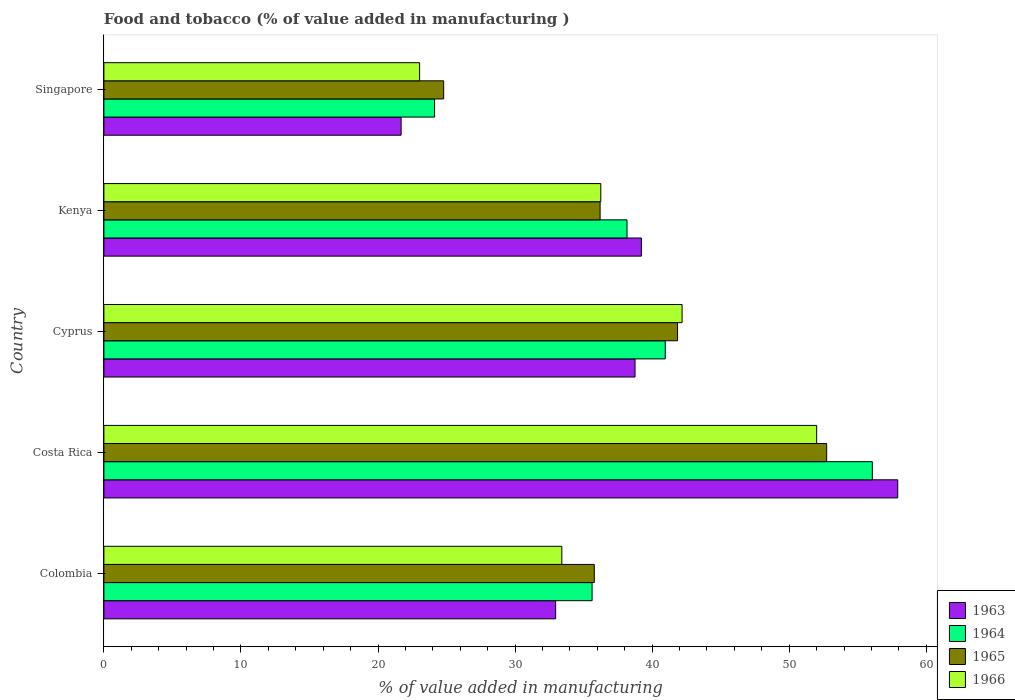How many groups of bars are there?
Provide a succinct answer. 5. Are the number of bars on each tick of the Y-axis equal?
Provide a succinct answer. Yes. How many bars are there on the 1st tick from the top?
Make the answer very short. 4. What is the value added in manufacturing food and tobacco in 1964 in Singapore?
Give a very brief answer. 24.13. Across all countries, what is the maximum value added in manufacturing food and tobacco in 1966?
Your response must be concise. 52. Across all countries, what is the minimum value added in manufacturing food and tobacco in 1966?
Your answer should be compact. 23.04. In which country was the value added in manufacturing food and tobacco in 1965 minimum?
Your answer should be compact. Singapore. What is the total value added in manufacturing food and tobacco in 1965 in the graph?
Offer a very short reply. 191.36. What is the difference between the value added in manufacturing food and tobacco in 1964 in Costa Rica and that in Cyprus?
Keep it short and to the point. 15.11. What is the difference between the value added in manufacturing food and tobacco in 1963 in Costa Rica and the value added in manufacturing food and tobacco in 1965 in Singapore?
Your answer should be very brief. 33.13. What is the average value added in manufacturing food and tobacco in 1966 per country?
Give a very brief answer. 37.38. What is the difference between the value added in manufacturing food and tobacco in 1963 and value added in manufacturing food and tobacco in 1966 in Costa Rica?
Provide a succinct answer. 5.92. In how many countries, is the value added in manufacturing food and tobacco in 1964 greater than 22 %?
Provide a short and direct response. 5. What is the ratio of the value added in manufacturing food and tobacco in 1964 in Costa Rica to that in Cyprus?
Give a very brief answer. 1.37. What is the difference between the highest and the second highest value added in manufacturing food and tobacco in 1963?
Offer a terse response. 18.7. What is the difference between the highest and the lowest value added in manufacturing food and tobacco in 1966?
Your answer should be compact. 28.97. In how many countries, is the value added in manufacturing food and tobacco in 1966 greater than the average value added in manufacturing food and tobacco in 1966 taken over all countries?
Provide a succinct answer. 2. Is the sum of the value added in manufacturing food and tobacco in 1966 in Costa Rica and Cyprus greater than the maximum value added in manufacturing food and tobacco in 1965 across all countries?
Keep it short and to the point. Yes. What does the 2nd bar from the bottom in Cyprus represents?
Provide a succinct answer. 1964. Is it the case that in every country, the sum of the value added in manufacturing food and tobacco in 1966 and value added in manufacturing food and tobacco in 1964 is greater than the value added in manufacturing food and tobacco in 1965?
Provide a short and direct response. Yes. How many bars are there?
Provide a succinct answer. 20. What is the difference between two consecutive major ticks on the X-axis?
Your answer should be very brief. 10. Are the values on the major ticks of X-axis written in scientific E-notation?
Provide a succinct answer. No. Does the graph contain any zero values?
Your answer should be compact. No. Where does the legend appear in the graph?
Make the answer very short. Bottom right. How many legend labels are there?
Your response must be concise. 4. How are the legend labels stacked?
Offer a very short reply. Vertical. What is the title of the graph?
Give a very brief answer. Food and tobacco (% of value added in manufacturing ). What is the label or title of the X-axis?
Your answer should be very brief. % of value added in manufacturing. What is the label or title of the Y-axis?
Keep it short and to the point. Country. What is the % of value added in manufacturing of 1963 in Colombia?
Keep it short and to the point. 32.96. What is the % of value added in manufacturing in 1964 in Colombia?
Give a very brief answer. 35.62. What is the % of value added in manufacturing of 1965 in Colombia?
Make the answer very short. 35.78. What is the % of value added in manufacturing in 1966 in Colombia?
Keep it short and to the point. 33.41. What is the % of value added in manufacturing in 1963 in Costa Rica?
Your answer should be compact. 57.92. What is the % of value added in manufacturing in 1964 in Costa Rica?
Your response must be concise. 56.07. What is the % of value added in manufacturing of 1965 in Costa Rica?
Your response must be concise. 52.73. What is the % of value added in manufacturing in 1966 in Costa Rica?
Offer a very short reply. 52. What is the % of value added in manufacturing in 1963 in Cyprus?
Offer a terse response. 38.75. What is the % of value added in manufacturing of 1964 in Cyprus?
Give a very brief answer. 40.96. What is the % of value added in manufacturing in 1965 in Cyprus?
Offer a very short reply. 41.85. What is the % of value added in manufacturing in 1966 in Cyprus?
Keep it short and to the point. 42.19. What is the % of value added in manufacturing in 1963 in Kenya?
Keep it short and to the point. 39.22. What is the % of value added in manufacturing in 1964 in Kenya?
Provide a short and direct response. 38.17. What is the % of value added in manufacturing of 1965 in Kenya?
Your answer should be compact. 36.2. What is the % of value added in manufacturing in 1966 in Kenya?
Give a very brief answer. 36.25. What is the % of value added in manufacturing in 1963 in Singapore?
Give a very brief answer. 21.69. What is the % of value added in manufacturing in 1964 in Singapore?
Provide a succinct answer. 24.13. What is the % of value added in manufacturing in 1965 in Singapore?
Your answer should be very brief. 24.79. What is the % of value added in manufacturing of 1966 in Singapore?
Your answer should be compact. 23.04. Across all countries, what is the maximum % of value added in manufacturing of 1963?
Offer a terse response. 57.92. Across all countries, what is the maximum % of value added in manufacturing of 1964?
Your response must be concise. 56.07. Across all countries, what is the maximum % of value added in manufacturing of 1965?
Offer a terse response. 52.73. Across all countries, what is the maximum % of value added in manufacturing in 1966?
Provide a succinct answer. 52. Across all countries, what is the minimum % of value added in manufacturing of 1963?
Your answer should be compact. 21.69. Across all countries, what is the minimum % of value added in manufacturing in 1964?
Give a very brief answer. 24.13. Across all countries, what is the minimum % of value added in manufacturing of 1965?
Keep it short and to the point. 24.79. Across all countries, what is the minimum % of value added in manufacturing in 1966?
Make the answer very short. 23.04. What is the total % of value added in manufacturing of 1963 in the graph?
Make the answer very short. 190.54. What is the total % of value added in manufacturing in 1964 in the graph?
Your response must be concise. 194.94. What is the total % of value added in manufacturing in 1965 in the graph?
Provide a succinct answer. 191.36. What is the total % of value added in manufacturing of 1966 in the graph?
Your answer should be compact. 186.89. What is the difference between the % of value added in manufacturing of 1963 in Colombia and that in Costa Rica?
Ensure brevity in your answer.  -24.96. What is the difference between the % of value added in manufacturing of 1964 in Colombia and that in Costa Rica?
Provide a short and direct response. -20.45. What is the difference between the % of value added in manufacturing in 1965 in Colombia and that in Costa Rica?
Provide a succinct answer. -16.95. What is the difference between the % of value added in manufacturing of 1966 in Colombia and that in Costa Rica?
Give a very brief answer. -18.59. What is the difference between the % of value added in manufacturing in 1963 in Colombia and that in Cyprus?
Offer a very short reply. -5.79. What is the difference between the % of value added in manufacturing in 1964 in Colombia and that in Cyprus?
Provide a succinct answer. -5.34. What is the difference between the % of value added in manufacturing in 1965 in Colombia and that in Cyprus?
Your response must be concise. -6.07. What is the difference between the % of value added in manufacturing of 1966 in Colombia and that in Cyprus?
Give a very brief answer. -8.78. What is the difference between the % of value added in manufacturing of 1963 in Colombia and that in Kenya?
Your answer should be very brief. -6.26. What is the difference between the % of value added in manufacturing in 1964 in Colombia and that in Kenya?
Give a very brief answer. -2.55. What is the difference between the % of value added in manufacturing in 1965 in Colombia and that in Kenya?
Your answer should be very brief. -0.42. What is the difference between the % of value added in manufacturing in 1966 in Colombia and that in Kenya?
Give a very brief answer. -2.84. What is the difference between the % of value added in manufacturing in 1963 in Colombia and that in Singapore?
Give a very brief answer. 11.27. What is the difference between the % of value added in manufacturing in 1964 in Colombia and that in Singapore?
Make the answer very short. 11.49. What is the difference between the % of value added in manufacturing in 1965 in Colombia and that in Singapore?
Keep it short and to the point. 10.99. What is the difference between the % of value added in manufacturing of 1966 in Colombia and that in Singapore?
Give a very brief answer. 10.37. What is the difference between the % of value added in manufacturing of 1963 in Costa Rica and that in Cyprus?
Ensure brevity in your answer.  19.17. What is the difference between the % of value added in manufacturing of 1964 in Costa Rica and that in Cyprus?
Give a very brief answer. 15.11. What is the difference between the % of value added in manufacturing in 1965 in Costa Rica and that in Cyprus?
Give a very brief answer. 10.88. What is the difference between the % of value added in manufacturing in 1966 in Costa Rica and that in Cyprus?
Your response must be concise. 9.82. What is the difference between the % of value added in manufacturing of 1963 in Costa Rica and that in Kenya?
Offer a very short reply. 18.7. What is the difference between the % of value added in manufacturing of 1964 in Costa Rica and that in Kenya?
Ensure brevity in your answer.  17.9. What is the difference between the % of value added in manufacturing in 1965 in Costa Rica and that in Kenya?
Provide a succinct answer. 16.53. What is the difference between the % of value added in manufacturing of 1966 in Costa Rica and that in Kenya?
Offer a very short reply. 15.75. What is the difference between the % of value added in manufacturing in 1963 in Costa Rica and that in Singapore?
Ensure brevity in your answer.  36.23. What is the difference between the % of value added in manufacturing in 1964 in Costa Rica and that in Singapore?
Keep it short and to the point. 31.94. What is the difference between the % of value added in manufacturing of 1965 in Costa Rica and that in Singapore?
Your response must be concise. 27.94. What is the difference between the % of value added in manufacturing in 1966 in Costa Rica and that in Singapore?
Offer a very short reply. 28.97. What is the difference between the % of value added in manufacturing in 1963 in Cyprus and that in Kenya?
Ensure brevity in your answer.  -0.46. What is the difference between the % of value added in manufacturing of 1964 in Cyprus and that in Kenya?
Provide a succinct answer. 2.79. What is the difference between the % of value added in manufacturing in 1965 in Cyprus and that in Kenya?
Your answer should be very brief. 5.65. What is the difference between the % of value added in manufacturing of 1966 in Cyprus and that in Kenya?
Make the answer very short. 5.93. What is the difference between the % of value added in manufacturing of 1963 in Cyprus and that in Singapore?
Your response must be concise. 17.07. What is the difference between the % of value added in manufacturing of 1964 in Cyprus and that in Singapore?
Ensure brevity in your answer.  16.83. What is the difference between the % of value added in manufacturing of 1965 in Cyprus and that in Singapore?
Your response must be concise. 17.06. What is the difference between the % of value added in manufacturing in 1966 in Cyprus and that in Singapore?
Offer a very short reply. 19.15. What is the difference between the % of value added in manufacturing of 1963 in Kenya and that in Singapore?
Provide a succinct answer. 17.53. What is the difference between the % of value added in manufacturing in 1964 in Kenya and that in Singapore?
Your response must be concise. 14.04. What is the difference between the % of value added in manufacturing in 1965 in Kenya and that in Singapore?
Your answer should be very brief. 11.41. What is the difference between the % of value added in manufacturing in 1966 in Kenya and that in Singapore?
Your response must be concise. 13.22. What is the difference between the % of value added in manufacturing in 1963 in Colombia and the % of value added in manufacturing in 1964 in Costa Rica?
Provide a succinct answer. -23.11. What is the difference between the % of value added in manufacturing of 1963 in Colombia and the % of value added in manufacturing of 1965 in Costa Rica?
Ensure brevity in your answer.  -19.77. What is the difference between the % of value added in manufacturing of 1963 in Colombia and the % of value added in manufacturing of 1966 in Costa Rica?
Your response must be concise. -19.04. What is the difference between the % of value added in manufacturing of 1964 in Colombia and the % of value added in manufacturing of 1965 in Costa Rica?
Offer a very short reply. -17.11. What is the difference between the % of value added in manufacturing in 1964 in Colombia and the % of value added in manufacturing in 1966 in Costa Rica?
Offer a very short reply. -16.38. What is the difference between the % of value added in manufacturing in 1965 in Colombia and the % of value added in manufacturing in 1966 in Costa Rica?
Keep it short and to the point. -16.22. What is the difference between the % of value added in manufacturing in 1963 in Colombia and the % of value added in manufacturing in 1964 in Cyprus?
Ensure brevity in your answer.  -8. What is the difference between the % of value added in manufacturing of 1963 in Colombia and the % of value added in manufacturing of 1965 in Cyprus?
Your response must be concise. -8.89. What is the difference between the % of value added in manufacturing in 1963 in Colombia and the % of value added in manufacturing in 1966 in Cyprus?
Provide a short and direct response. -9.23. What is the difference between the % of value added in manufacturing in 1964 in Colombia and the % of value added in manufacturing in 1965 in Cyprus?
Offer a terse response. -6.23. What is the difference between the % of value added in manufacturing in 1964 in Colombia and the % of value added in manufacturing in 1966 in Cyprus?
Your answer should be compact. -6.57. What is the difference between the % of value added in manufacturing of 1965 in Colombia and the % of value added in manufacturing of 1966 in Cyprus?
Offer a very short reply. -6.41. What is the difference between the % of value added in manufacturing of 1963 in Colombia and the % of value added in manufacturing of 1964 in Kenya?
Offer a very short reply. -5.21. What is the difference between the % of value added in manufacturing of 1963 in Colombia and the % of value added in manufacturing of 1965 in Kenya?
Provide a succinct answer. -3.24. What is the difference between the % of value added in manufacturing in 1963 in Colombia and the % of value added in manufacturing in 1966 in Kenya?
Provide a succinct answer. -3.29. What is the difference between the % of value added in manufacturing of 1964 in Colombia and the % of value added in manufacturing of 1965 in Kenya?
Provide a succinct answer. -0.58. What is the difference between the % of value added in manufacturing in 1964 in Colombia and the % of value added in manufacturing in 1966 in Kenya?
Offer a terse response. -0.63. What is the difference between the % of value added in manufacturing in 1965 in Colombia and the % of value added in manufacturing in 1966 in Kenya?
Provide a succinct answer. -0.47. What is the difference between the % of value added in manufacturing of 1963 in Colombia and the % of value added in manufacturing of 1964 in Singapore?
Your response must be concise. 8.83. What is the difference between the % of value added in manufacturing of 1963 in Colombia and the % of value added in manufacturing of 1965 in Singapore?
Ensure brevity in your answer.  8.17. What is the difference between the % of value added in manufacturing in 1963 in Colombia and the % of value added in manufacturing in 1966 in Singapore?
Your answer should be very brief. 9.92. What is the difference between the % of value added in manufacturing of 1964 in Colombia and the % of value added in manufacturing of 1965 in Singapore?
Provide a succinct answer. 10.83. What is the difference between the % of value added in manufacturing of 1964 in Colombia and the % of value added in manufacturing of 1966 in Singapore?
Your response must be concise. 12.58. What is the difference between the % of value added in manufacturing in 1965 in Colombia and the % of value added in manufacturing in 1966 in Singapore?
Offer a very short reply. 12.74. What is the difference between the % of value added in manufacturing of 1963 in Costa Rica and the % of value added in manufacturing of 1964 in Cyprus?
Your response must be concise. 16.96. What is the difference between the % of value added in manufacturing of 1963 in Costa Rica and the % of value added in manufacturing of 1965 in Cyprus?
Offer a very short reply. 16.07. What is the difference between the % of value added in manufacturing in 1963 in Costa Rica and the % of value added in manufacturing in 1966 in Cyprus?
Provide a succinct answer. 15.73. What is the difference between the % of value added in manufacturing in 1964 in Costa Rica and the % of value added in manufacturing in 1965 in Cyprus?
Make the answer very short. 14.21. What is the difference between the % of value added in manufacturing of 1964 in Costa Rica and the % of value added in manufacturing of 1966 in Cyprus?
Make the answer very short. 13.88. What is the difference between the % of value added in manufacturing in 1965 in Costa Rica and the % of value added in manufacturing in 1966 in Cyprus?
Your answer should be compact. 10.55. What is the difference between the % of value added in manufacturing of 1963 in Costa Rica and the % of value added in manufacturing of 1964 in Kenya?
Give a very brief answer. 19.75. What is the difference between the % of value added in manufacturing in 1963 in Costa Rica and the % of value added in manufacturing in 1965 in Kenya?
Ensure brevity in your answer.  21.72. What is the difference between the % of value added in manufacturing of 1963 in Costa Rica and the % of value added in manufacturing of 1966 in Kenya?
Offer a terse response. 21.67. What is the difference between the % of value added in manufacturing in 1964 in Costa Rica and the % of value added in manufacturing in 1965 in Kenya?
Offer a terse response. 19.86. What is the difference between the % of value added in manufacturing in 1964 in Costa Rica and the % of value added in manufacturing in 1966 in Kenya?
Keep it short and to the point. 19.81. What is the difference between the % of value added in manufacturing of 1965 in Costa Rica and the % of value added in manufacturing of 1966 in Kenya?
Offer a very short reply. 16.48. What is the difference between the % of value added in manufacturing in 1963 in Costa Rica and the % of value added in manufacturing in 1964 in Singapore?
Provide a succinct answer. 33.79. What is the difference between the % of value added in manufacturing of 1963 in Costa Rica and the % of value added in manufacturing of 1965 in Singapore?
Give a very brief answer. 33.13. What is the difference between the % of value added in manufacturing of 1963 in Costa Rica and the % of value added in manufacturing of 1966 in Singapore?
Provide a succinct answer. 34.88. What is the difference between the % of value added in manufacturing in 1964 in Costa Rica and the % of value added in manufacturing in 1965 in Singapore?
Ensure brevity in your answer.  31.28. What is the difference between the % of value added in manufacturing of 1964 in Costa Rica and the % of value added in manufacturing of 1966 in Singapore?
Make the answer very short. 33.03. What is the difference between the % of value added in manufacturing of 1965 in Costa Rica and the % of value added in manufacturing of 1966 in Singapore?
Make the answer very short. 29.7. What is the difference between the % of value added in manufacturing of 1963 in Cyprus and the % of value added in manufacturing of 1964 in Kenya?
Keep it short and to the point. 0.59. What is the difference between the % of value added in manufacturing of 1963 in Cyprus and the % of value added in manufacturing of 1965 in Kenya?
Provide a succinct answer. 2.55. What is the difference between the % of value added in manufacturing in 1963 in Cyprus and the % of value added in manufacturing in 1966 in Kenya?
Make the answer very short. 2.5. What is the difference between the % of value added in manufacturing of 1964 in Cyprus and the % of value added in manufacturing of 1965 in Kenya?
Offer a terse response. 4.75. What is the difference between the % of value added in manufacturing in 1964 in Cyprus and the % of value added in manufacturing in 1966 in Kenya?
Provide a succinct answer. 4.7. What is the difference between the % of value added in manufacturing of 1965 in Cyprus and the % of value added in manufacturing of 1966 in Kenya?
Make the answer very short. 5.6. What is the difference between the % of value added in manufacturing in 1963 in Cyprus and the % of value added in manufacturing in 1964 in Singapore?
Your response must be concise. 14.63. What is the difference between the % of value added in manufacturing of 1963 in Cyprus and the % of value added in manufacturing of 1965 in Singapore?
Offer a terse response. 13.96. What is the difference between the % of value added in manufacturing of 1963 in Cyprus and the % of value added in manufacturing of 1966 in Singapore?
Offer a very short reply. 15.72. What is the difference between the % of value added in manufacturing of 1964 in Cyprus and the % of value added in manufacturing of 1965 in Singapore?
Make the answer very short. 16.17. What is the difference between the % of value added in manufacturing of 1964 in Cyprus and the % of value added in manufacturing of 1966 in Singapore?
Give a very brief answer. 17.92. What is the difference between the % of value added in manufacturing in 1965 in Cyprus and the % of value added in manufacturing in 1966 in Singapore?
Offer a terse response. 18.82. What is the difference between the % of value added in manufacturing in 1963 in Kenya and the % of value added in manufacturing in 1964 in Singapore?
Make the answer very short. 15.09. What is the difference between the % of value added in manufacturing of 1963 in Kenya and the % of value added in manufacturing of 1965 in Singapore?
Make the answer very short. 14.43. What is the difference between the % of value added in manufacturing in 1963 in Kenya and the % of value added in manufacturing in 1966 in Singapore?
Provide a succinct answer. 16.18. What is the difference between the % of value added in manufacturing in 1964 in Kenya and the % of value added in manufacturing in 1965 in Singapore?
Provide a short and direct response. 13.38. What is the difference between the % of value added in manufacturing in 1964 in Kenya and the % of value added in manufacturing in 1966 in Singapore?
Give a very brief answer. 15.13. What is the difference between the % of value added in manufacturing of 1965 in Kenya and the % of value added in manufacturing of 1966 in Singapore?
Ensure brevity in your answer.  13.17. What is the average % of value added in manufacturing of 1963 per country?
Provide a short and direct response. 38.11. What is the average % of value added in manufacturing of 1964 per country?
Give a very brief answer. 38.99. What is the average % of value added in manufacturing of 1965 per country?
Keep it short and to the point. 38.27. What is the average % of value added in manufacturing in 1966 per country?
Give a very brief answer. 37.38. What is the difference between the % of value added in manufacturing in 1963 and % of value added in manufacturing in 1964 in Colombia?
Ensure brevity in your answer.  -2.66. What is the difference between the % of value added in manufacturing of 1963 and % of value added in manufacturing of 1965 in Colombia?
Make the answer very short. -2.82. What is the difference between the % of value added in manufacturing of 1963 and % of value added in manufacturing of 1966 in Colombia?
Make the answer very short. -0.45. What is the difference between the % of value added in manufacturing of 1964 and % of value added in manufacturing of 1965 in Colombia?
Your answer should be compact. -0.16. What is the difference between the % of value added in manufacturing of 1964 and % of value added in manufacturing of 1966 in Colombia?
Make the answer very short. 2.21. What is the difference between the % of value added in manufacturing in 1965 and % of value added in manufacturing in 1966 in Colombia?
Provide a short and direct response. 2.37. What is the difference between the % of value added in manufacturing of 1963 and % of value added in manufacturing of 1964 in Costa Rica?
Give a very brief answer. 1.85. What is the difference between the % of value added in manufacturing of 1963 and % of value added in manufacturing of 1965 in Costa Rica?
Your response must be concise. 5.19. What is the difference between the % of value added in manufacturing of 1963 and % of value added in manufacturing of 1966 in Costa Rica?
Your response must be concise. 5.92. What is the difference between the % of value added in manufacturing of 1964 and % of value added in manufacturing of 1965 in Costa Rica?
Make the answer very short. 3.33. What is the difference between the % of value added in manufacturing in 1964 and % of value added in manufacturing in 1966 in Costa Rica?
Ensure brevity in your answer.  4.06. What is the difference between the % of value added in manufacturing of 1965 and % of value added in manufacturing of 1966 in Costa Rica?
Provide a succinct answer. 0.73. What is the difference between the % of value added in manufacturing of 1963 and % of value added in manufacturing of 1964 in Cyprus?
Your answer should be compact. -2.2. What is the difference between the % of value added in manufacturing of 1963 and % of value added in manufacturing of 1965 in Cyprus?
Offer a terse response. -3.1. What is the difference between the % of value added in manufacturing of 1963 and % of value added in manufacturing of 1966 in Cyprus?
Your response must be concise. -3.43. What is the difference between the % of value added in manufacturing in 1964 and % of value added in manufacturing in 1965 in Cyprus?
Ensure brevity in your answer.  -0.9. What is the difference between the % of value added in manufacturing of 1964 and % of value added in manufacturing of 1966 in Cyprus?
Ensure brevity in your answer.  -1.23. What is the difference between the % of value added in manufacturing in 1965 and % of value added in manufacturing in 1966 in Cyprus?
Offer a very short reply. -0.33. What is the difference between the % of value added in manufacturing of 1963 and % of value added in manufacturing of 1964 in Kenya?
Provide a succinct answer. 1.05. What is the difference between the % of value added in manufacturing of 1963 and % of value added in manufacturing of 1965 in Kenya?
Give a very brief answer. 3.01. What is the difference between the % of value added in manufacturing in 1963 and % of value added in manufacturing in 1966 in Kenya?
Make the answer very short. 2.96. What is the difference between the % of value added in manufacturing in 1964 and % of value added in manufacturing in 1965 in Kenya?
Your answer should be very brief. 1.96. What is the difference between the % of value added in manufacturing of 1964 and % of value added in manufacturing of 1966 in Kenya?
Offer a terse response. 1.91. What is the difference between the % of value added in manufacturing in 1963 and % of value added in manufacturing in 1964 in Singapore?
Make the answer very short. -2.44. What is the difference between the % of value added in manufacturing in 1963 and % of value added in manufacturing in 1965 in Singapore?
Your answer should be very brief. -3.1. What is the difference between the % of value added in manufacturing of 1963 and % of value added in manufacturing of 1966 in Singapore?
Your answer should be very brief. -1.35. What is the difference between the % of value added in manufacturing in 1964 and % of value added in manufacturing in 1965 in Singapore?
Your response must be concise. -0.66. What is the difference between the % of value added in manufacturing of 1964 and % of value added in manufacturing of 1966 in Singapore?
Your answer should be very brief. 1.09. What is the difference between the % of value added in manufacturing in 1965 and % of value added in manufacturing in 1966 in Singapore?
Provide a succinct answer. 1.75. What is the ratio of the % of value added in manufacturing in 1963 in Colombia to that in Costa Rica?
Provide a short and direct response. 0.57. What is the ratio of the % of value added in manufacturing of 1964 in Colombia to that in Costa Rica?
Your response must be concise. 0.64. What is the ratio of the % of value added in manufacturing in 1965 in Colombia to that in Costa Rica?
Offer a terse response. 0.68. What is the ratio of the % of value added in manufacturing of 1966 in Colombia to that in Costa Rica?
Offer a very short reply. 0.64. What is the ratio of the % of value added in manufacturing in 1963 in Colombia to that in Cyprus?
Your response must be concise. 0.85. What is the ratio of the % of value added in manufacturing of 1964 in Colombia to that in Cyprus?
Make the answer very short. 0.87. What is the ratio of the % of value added in manufacturing in 1965 in Colombia to that in Cyprus?
Ensure brevity in your answer.  0.85. What is the ratio of the % of value added in manufacturing in 1966 in Colombia to that in Cyprus?
Offer a very short reply. 0.79. What is the ratio of the % of value added in manufacturing of 1963 in Colombia to that in Kenya?
Provide a short and direct response. 0.84. What is the ratio of the % of value added in manufacturing of 1964 in Colombia to that in Kenya?
Keep it short and to the point. 0.93. What is the ratio of the % of value added in manufacturing in 1965 in Colombia to that in Kenya?
Your answer should be compact. 0.99. What is the ratio of the % of value added in manufacturing of 1966 in Colombia to that in Kenya?
Make the answer very short. 0.92. What is the ratio of the % of value added in manufacturing of 1963 in Colombia to that in Singapore?
Your response must be concise. 1.52. What is the ratio of the % of value added in manufacturing of 1964 in Colombia to that in Singapore?
Make the answer very short. 1.48. What is the ratio of the % of value added in manufacturing of 1965 in Colombia to that in Singapore?
Ensure brevity in your answer.  1.44. What is the ratio of the % of value added in manufacturing of 1966 in Colombia to that in Singapore?
Provide a succinct answer. 1.45. What is the ratio of the % of value added in manufacturing of 1963 in Costa Rica to that in Cyprus?
Your response must be concise. 1.49. What is the ratio of the % of value added in manufacturing in 1964 in Costa Rica to that in Cyprus?
Your response must be concise. 1.37. What is the ratio of the % of value added in manufacturing of 1965 in Costa Rica to that in Cyprus?
Keep it short and to the point. 1.26. What is the ratio of the % of value added in manufacturing of 1966 in Costa Rica to that in Cyprus?
Offer a very short reply. 1.23. What is the ratio of the % of value added in manufacturing in 1963 in Costa Rica to that in Kenya?
Provide a short and direct response. 1.48. What is the ratio of the % of value added in manufacturing of 1964 in Costa Rica to that in Kenya?
Make the answer very short. 1.47. What is the ratio of the % of value added in manufacturing of 1965 in Costa Rica to that in Kenya?
Your response must be concise. 1.46. What is the ratio of the % of value added in manufacturing of 1966 in Costa Rica to that in Kenya?
Your response must be concise. 1.43. What is the ratio of the % of value added in manufacturing of 1963 in Costa Rica to that in Singapore?
Your answer should be very brief. 2.67. What is the ratio of the % of value added in manufacturing in 1964 in Costa Rica to that in Singapore?
Your answer should be compact. 2.32. What is the ratio of the % of value added in manufacturing of 1965 in Costa Rica to that in Singapore?
Provide a succinct answer. 2.13. What is the ratio of the % of value added in manufacturing in 1966 in Costa Rica to that in Singapore?
Your answer should be compact. 2.26. What is the ratio of the % of value added in manufacturing of 1963 in Cyprus to that in Kenya?
Provide a short and direct response. 0.99. What is the ratio of the % of value added in manufacturing in 1964 in Cyprus to that in Kenya?
Keep it short and to the point. 1.07. What is the ratio of the % of value added in manufacturing of 1965 in Cyprus to that in Kenya?
Ensure brevity in your answer.  1.16. What is the ratio of the % of value added in manufacturing in 1966 in Cyprus to that in Kenya?
Offer a terse response. 1.16. What is the ratio of the % of value added in manufacturing of 1963 in Cyprus to that in Singapore?
Make the answer very short. 1.79. What is the ratio of the % of value added in manufacturing of 1964 in Cyprus to that in Singapore?
Give a very brief answer. 1.7. What is the ratio of the % of value added in manufacturing of 1965 in Cyprus to that in Singapore?
Your answer should be compact. 1.69. What is the ratio of the % of value added in manufacturing in 1966 in Cyprus to that in Singapore?
Provide a succinct answer. 1.83. What is the ratio of the % of value added in manufacturing in 1963 in Kenya to that in Singapore?
Your response must be concise. 1.81. What is the ratio of the % of value added in manufacturing in 1964 in Kenya to that in Singapore?
Your answer should be very brief. 1.58. What is the ratio of the % of value added in manufacturing in 1965 in Kenya to that in Singapore?
Keep it short and to the point. 1.46. What is the ratio of the % of value added in manufacturing of 1966 in Kenya to that in Singapore?
Offer a terse response. 1.57. What is the difference between the highest and the second highest % of value added in manufacturing of 1963?
Your answer should be very brief. 18.7. What is the difference between the highest and the second highest % of value added in manufacturing in 1964?
Offer a very short reply. 15.11. What is the difference between the highest and the second highest % of value added in manufacturing of 1965?
Your response must be concise. 10.88. What is the difference between the highest and the second highest % of value added in manufacturing of 1966?
Give a very brief answer. 9.82. What is the difference between the highest and the lowest % of value added in manufacturing in 1963?
Your answer should be very brief. 36.23. What is the difference between the highest and the lowest % of value added in manufacturing in 1964?
Provide a succinct answer. 31.94. What is the difference between the highest and the lowest % of value added in manufacturing in 1965?
Provide a short and direct response. 27.94. What is the difference between the highest and the lowest % of value added in manufacturing of 1966?
Your answer should be very brief. 28.97. 